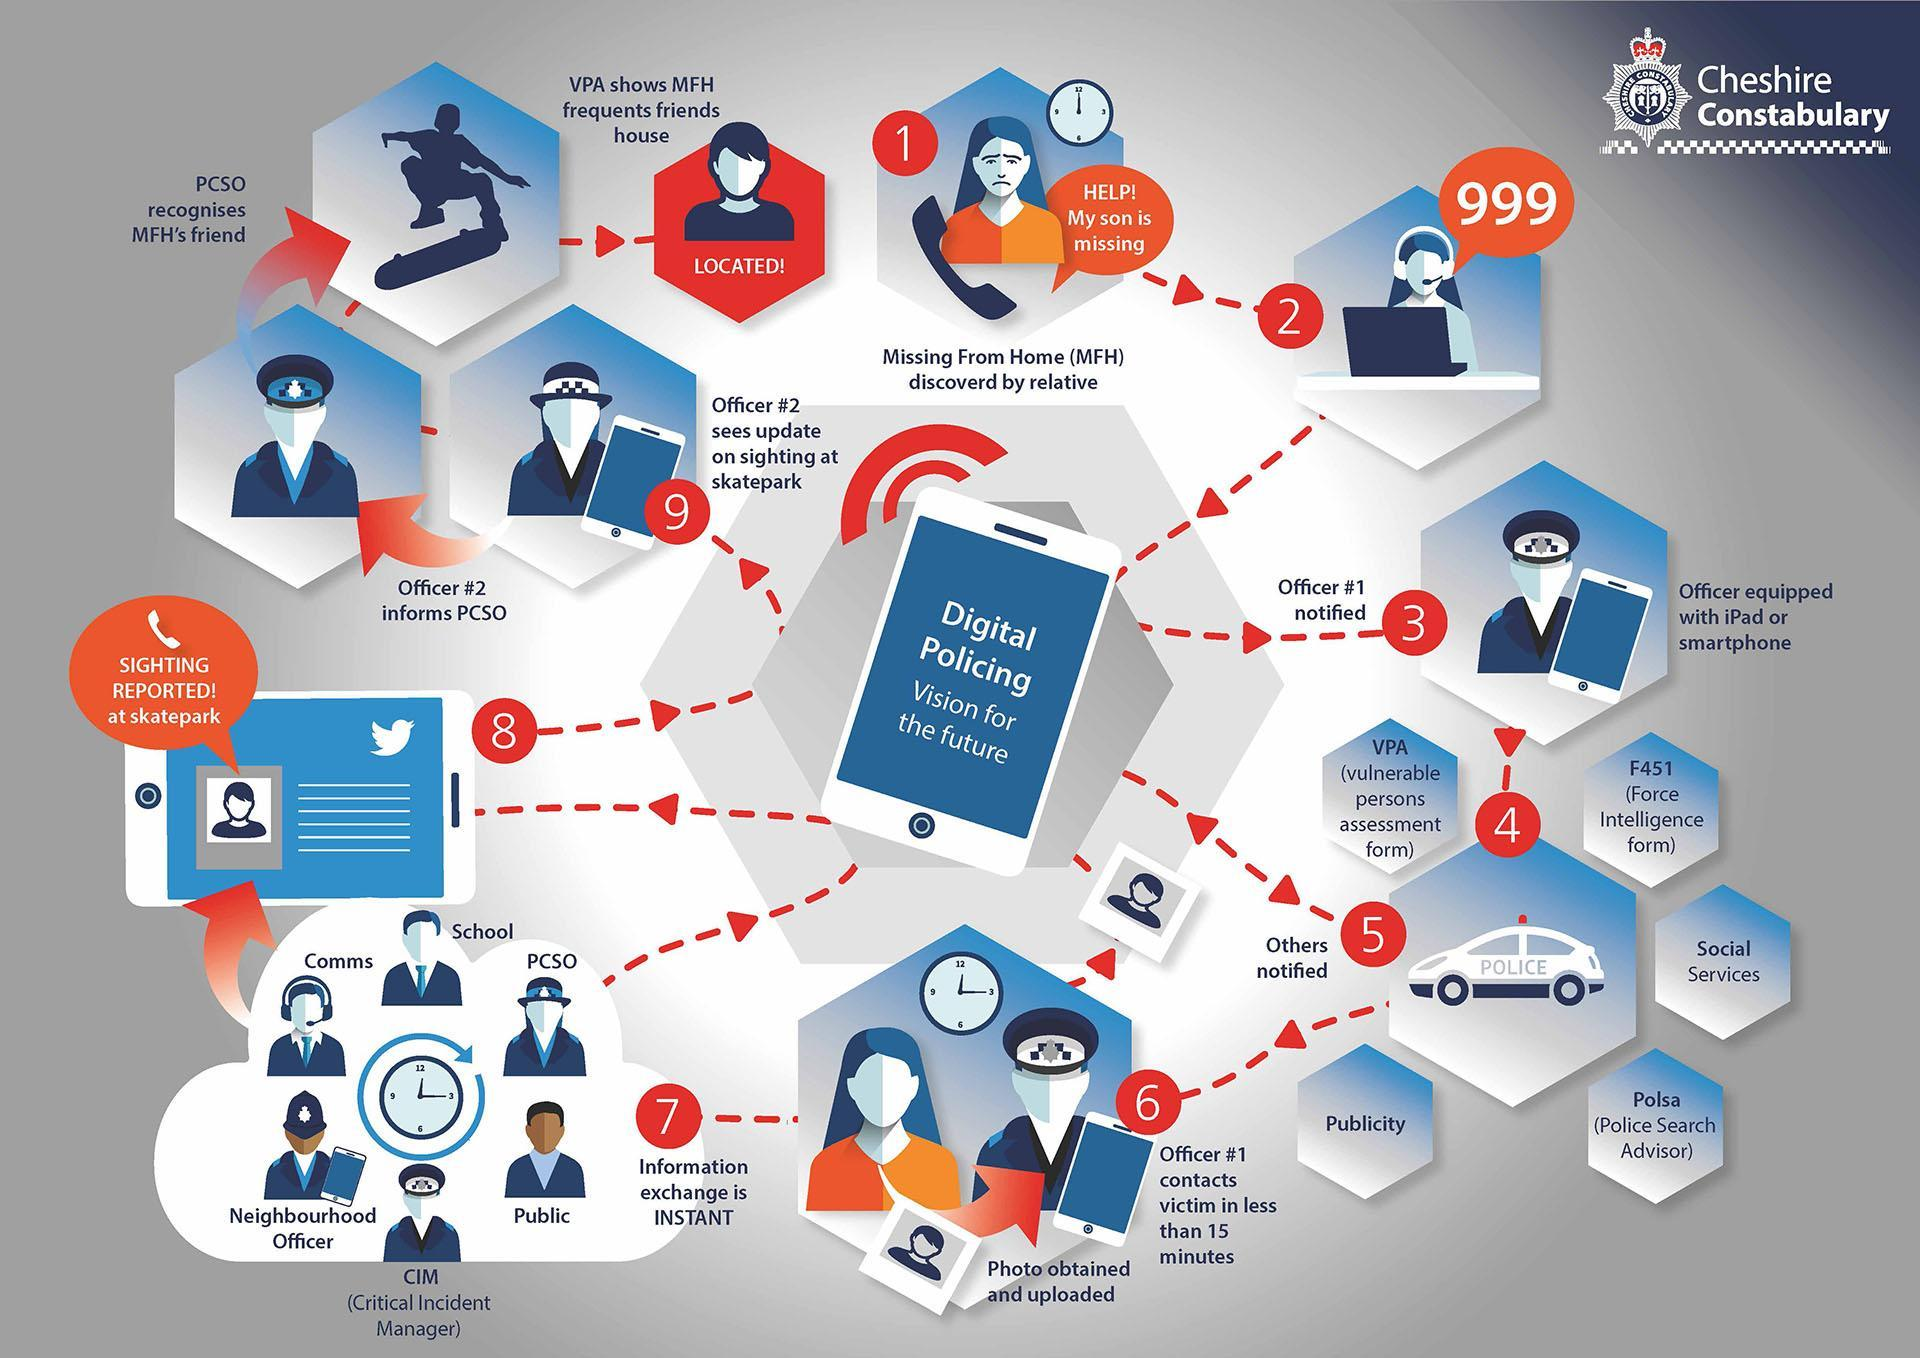What is written inside the image of the smart phone?
Answer the question with a short phrase. Digital Policing Vision for the Future How many people are involved during information exchange process? 6 Where is the missing from home case first reported? 999 Which step suggests that the victim has been found ? Step 9 